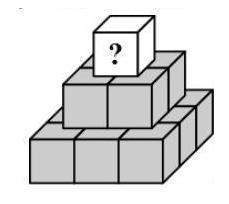Is there a mathematical strategy to distribute the numbers to maximize the value on the top cube? Indeed, there is! A systematic strategy involves starting with the smallest numbers on the bottom layer and then assigning numbers to the second layer such that they create the largest possible sums while still using unique positive whole numbers. For the third layer, repeat this process. The goal is to keep the increment between the numbers in each layer as uniform as possible, balancing the values to optimize the number on top. 